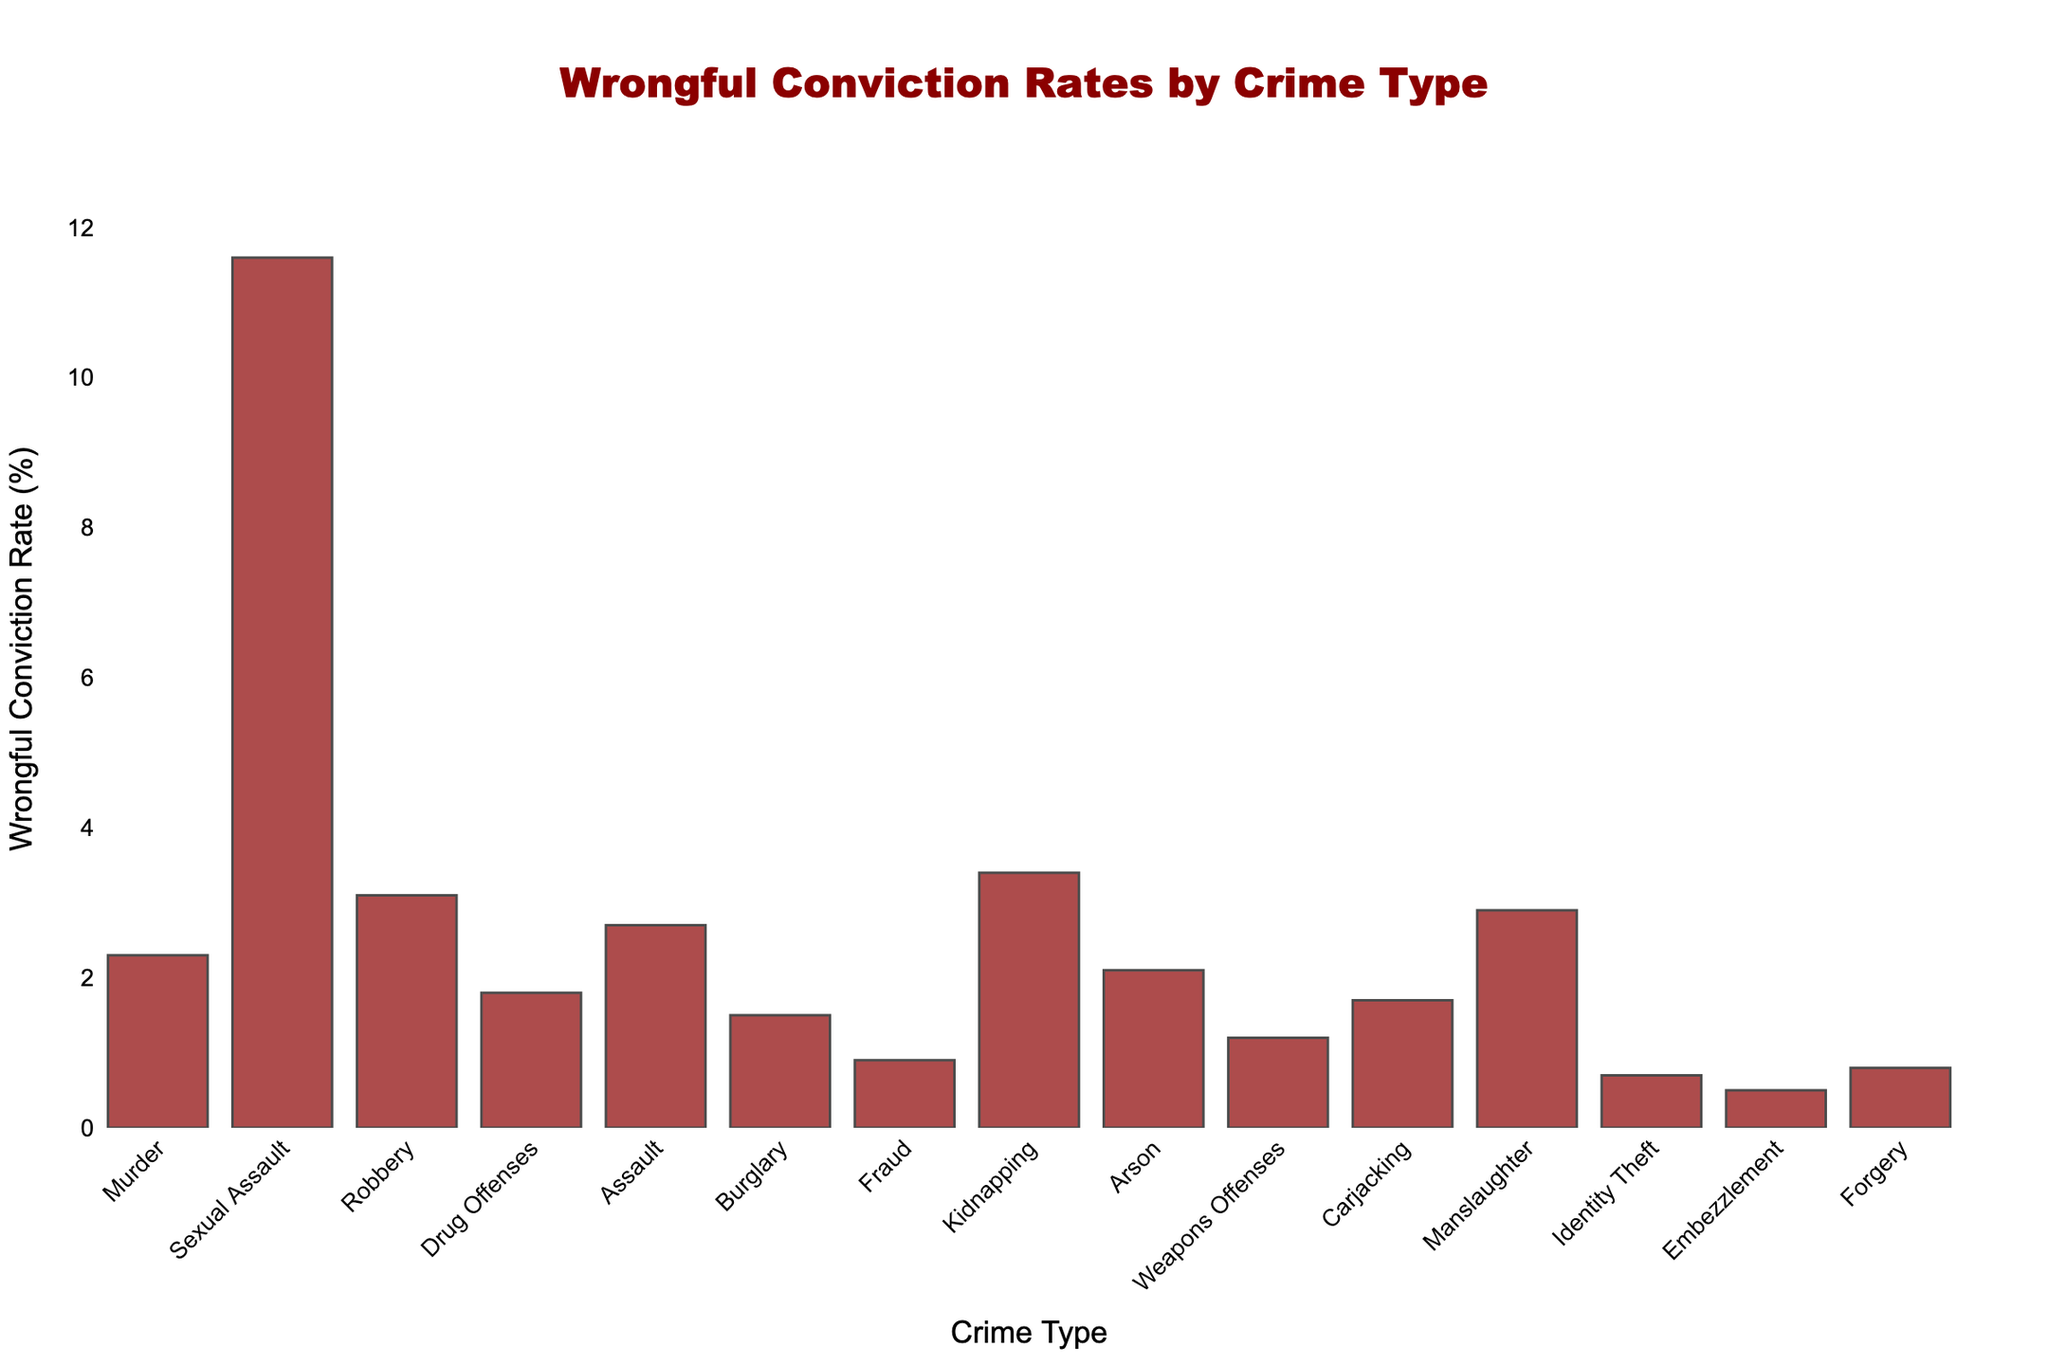Which crime type has the highest wrongful conviction rate? The bar chart shows wrongful conviction rates for various crime types. The highest bar represents Sexual Assault with an 11.6% wrongful conviction rate.
Answer: Sexual Assault What is the sum of wrongful conviction rates for Fraud, Embezzlement, and Forgery? Add the wrongful conviction rates for these crimes: Fraud (0.9%), Embezzlement (0.5%), and Forgery (0.8%). The total is 0.9 + 0.5 + 0.8 = 2.2%.
Answer: 2.2% Which crime types have wrongful conviction rates greater than 3%? The bars representing Robbery (3.1%), Sexual Assault (11.6%), Kidnapping (3.4%), and Manslaughter (2.9%) are all greater than 3%.
Answer: Robbery, Sexual Assault, Kidnapping How does the wrongful conviction rate for Murder compare to that for Robbery? The bar for Murder is 2.3%, and the bar for Robbery is 3.1%. Robbery has a higher rate.
Answer: Robbery is higher What is the difference in wrongful conviction rates between Carjacking and Burglary? The bar for Carjacking shows 1.7% and for Burglary 1.5%. The difference is 1.7 - 1.5 = 0.2%.
Answer: 0.2% What visual attribute indicates the variance in wrongful conviction rates? The height of the bars visually represents the variance in wrongful conviction rates, with taller bars indicating higher rates.
Answer: Height of bars What's the average wrongful conviction rate of the three crimes with the highest rates? The three crimes with the highest rates are Sexual Assault (11.6%), Kidnapping (3.4%), and Robbery (3.1%). The average is (11.6 + 3.4 + 3.1) / 3 = 6.03%.
Answer: 6.03% Which crime type has the lowest wrongful conviction rate? The bar chart shows the lowest bar for Embezzlement at 0.5%.
Answer: Embezzlement Compare the wrongful conviction rates of Arson and Weapons Offenses. The bar for Arson shows 2.1%, and the bar for Weapons Offenses shows 1.2%. Arson has a higher wrongful conviction rate.
Answer: Arson is higher What is the total wrongful conviction rate for the crimes involving property (Burglary, Fraud, Embezzlement, Identity Theft, and Forgery)? Add the rates: Burglary (1.5%), Fraud (0.9%), Embezzlement (0.5%), Identity Theft (0.7%), and Forgery (0.8%). The total is 1.5 + 0.9 + 0.5 + 0.7 + 0.8 = 4.4%.
Answer: 4.4% 